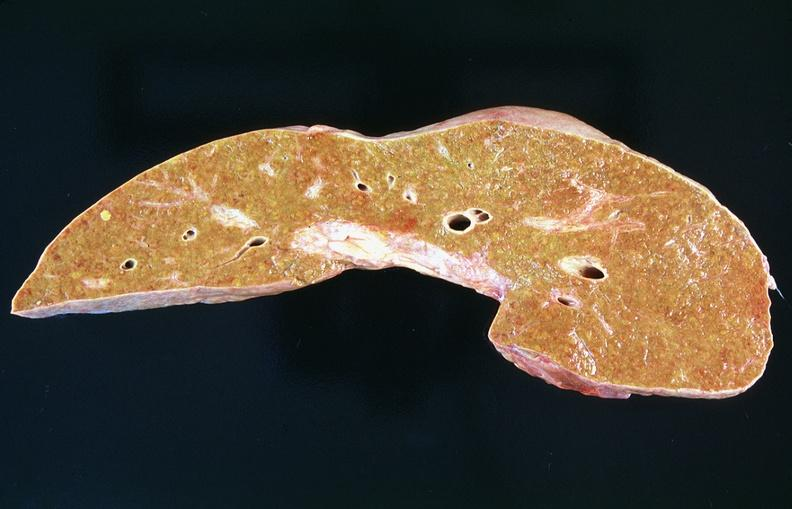how many antitrypsin does this image show liver, cirrhosis alpha-deficiency?
Answer the question using a single word or phrase. 1 